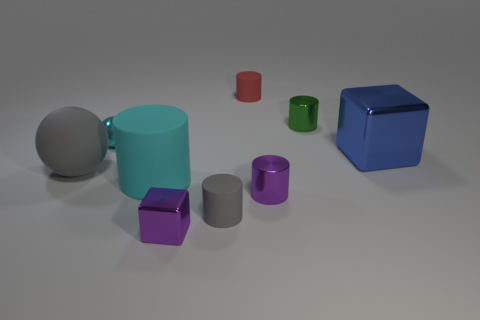Subtract all purple cylinders. How many cylinders are left? 4 Subtract all small purple metal cylinders. How many cylinders are left? 4 Subtract 1 cylinders. How many cylinders are left? 4 Subtract all brown cylinders. Subtract all gray balls. How many cylinders are left? 5 Add 1 purple things. How many objects exist? 10 Subtract all balls. How many objects are left? 7 Subtract 0 yellow cylinders. How many objects are left? 9 Subtract all large blue cubes. Subtract all cyan objects. How many objects are left? 6 Add 2 green objects. How many green objects are left? 3 Add 8 yellow cylinders. How many yellow cylinders exist? 8 